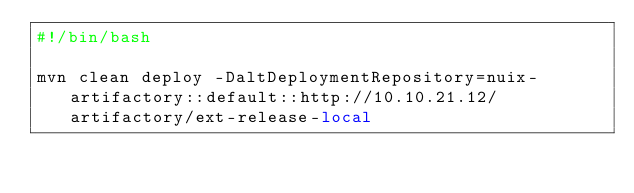<code> <loc_0><loc_0><loc_500><loc_500><_Bash_>#!/bin/bash

mvn clean deploy -DaltDeploymentRepository=nuix-artifactory::default::http://10.10.21.12/artifactory/ext-release-local</code> 